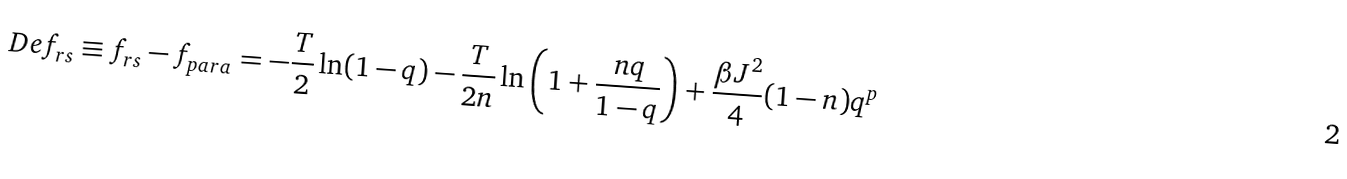Convert formula to latex. <formula><loc_0><loc_0><loc_500><loc_500>\ D e f _ { r s } \equiv f _ { r s } - f _ { p a r a } = - \frac { T } { 2 } \ln ( 1 - q ) - \frac { T } { 2 n } \ln \left ( 1 + \frac { n q } { 1 - q } \right ) + \frac { \beta J ^ { 2 } } { 4 } ( 1 - n ) q ^ { p }</formula> 